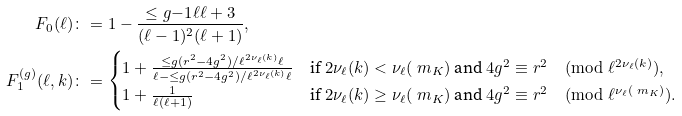Convert formula to latex. <formula><loc_0><loc_0><loc_500><loc_500>F _ { 0 } ( \ell ) & \colon = 1 - \frac { \leq g { - 1 } { \ell } \ell + 3 } { ( \ell - 1 ) ^ { 2 } ( \ell + 1 ) } , \\ F _ { 1 } ^ { ( g ) } ( \ell , k ) & \colon = \begin{cases} 1 + \frac { \leq g { ( r ^ { 2 } - 4 g ^ { 2 } ) / \ell ^ { 2 \nu _ { \ell } ( k ) } } { \ell } } { \ell - \leq g { ( r ^ { 2 } - 4 g ^ { 2 } ) / \ell ^ { 2 \nu _ { \ell } ( k ) } } { \ell } } & \text {if } 2 \nu _ { \ell } ( k ) < \nu _ { \ell } ( \ m _ { K } ) \text { and } 4 g ^ { 2 } \equiv r ^ { 2 } \pmod { \ell ^ { 2 \nu _ { \ell } ( k ) } } , \\ 1 + \frac { 1 } { \ell ( \ell + 1 ) } & \text {if } 2 \nu _ { \ell } ( k ) \geq \nu _ { \ell } ( \ m _ { K } ) \text { and } 4 g ^ { 2 } \equiv r ^ { 2 } \pmod { \ell ^ { \nu _ { \ell } ( \ m _ { K } ) } } . \\ \end{cases}</formula> 